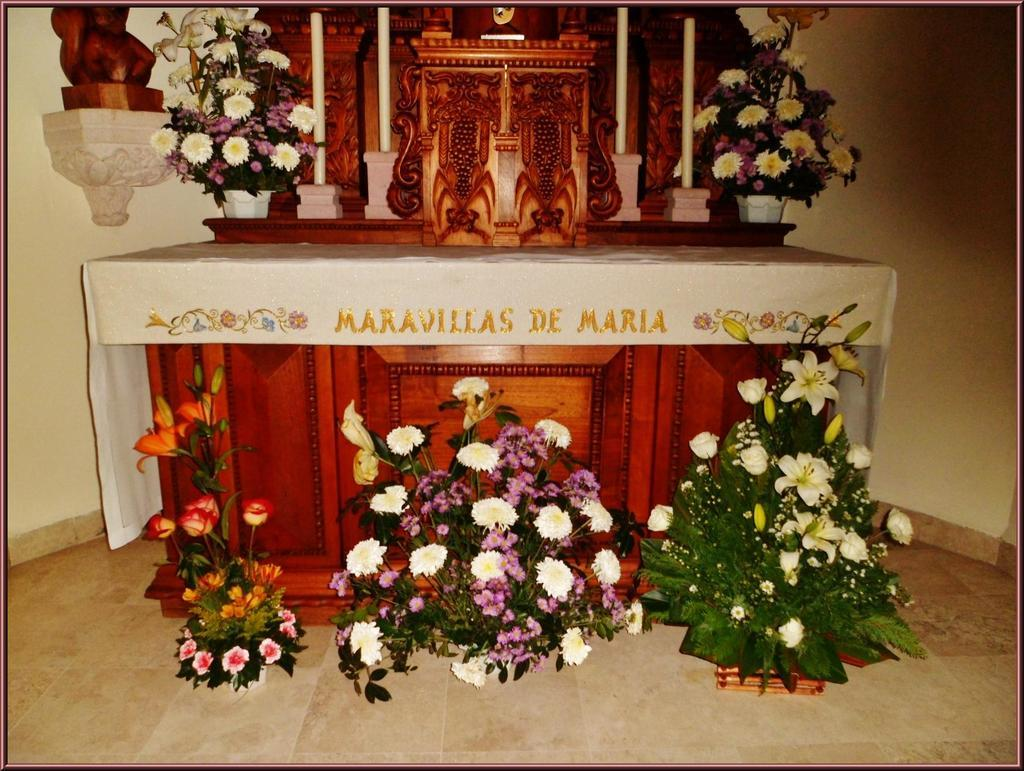What type of furniture is in the image? There is a table in the image. What can be seen on the table? Text is present in the image, along with bouquets. What type of material is visible in the image? There is cloth in the image. What is visible in the background of the image? There is a wall in the background of the image. What is visible at the bottom of the image? The floor is visible at the bottom of the image. Can you see any brass instruments at the seashore in the image? There is no seashore or brass instruments present in the image. What type of reward is being given to the person in the image? There is no person or reward present in the image. 